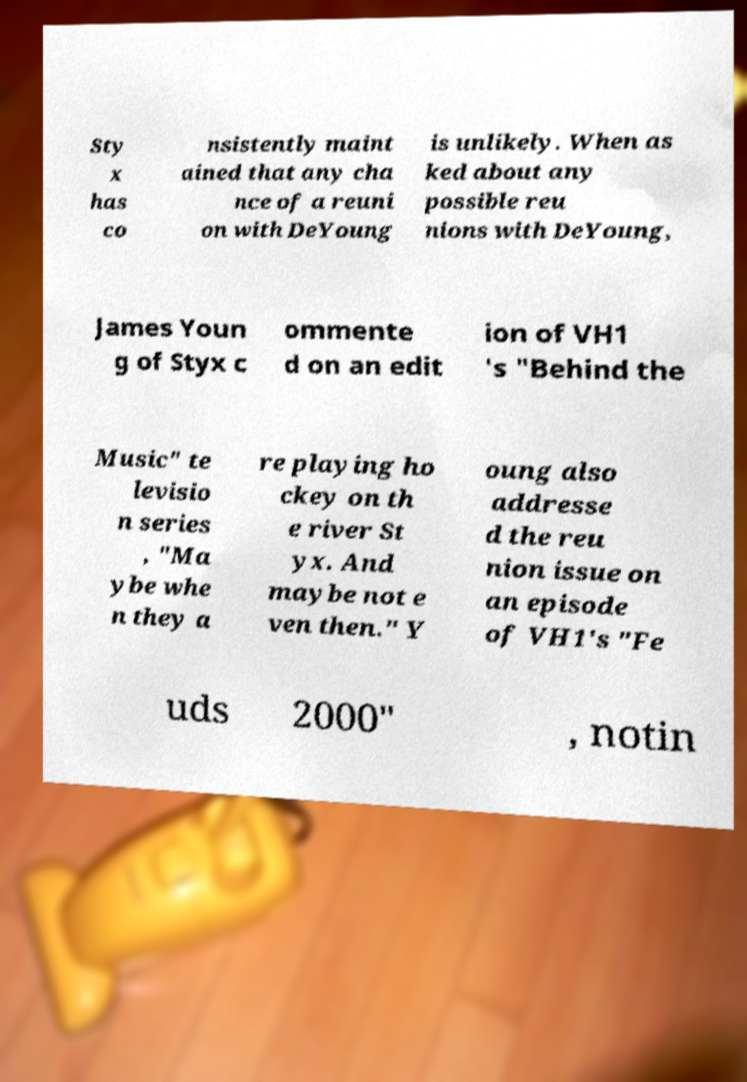There's text embedded in this image that I need extracted. Can you transcribe it verbatim? Sty x has co nsistently maint ained that any cha nce of a reuni on with DeYoung is unlikely. When as ked about any possible reu nions with DeYoung, James Youn g of Styx c ommente d on an edit ion of VH1 's "Behind the Music" te levisio n series , "Ma ybe whe n they a re playing ho ckey on th e river St yx. And maybe not e ven then." Y oung also addresse d the reu nion issue on an episode of VH1's "Fe uds 2000" , notin 